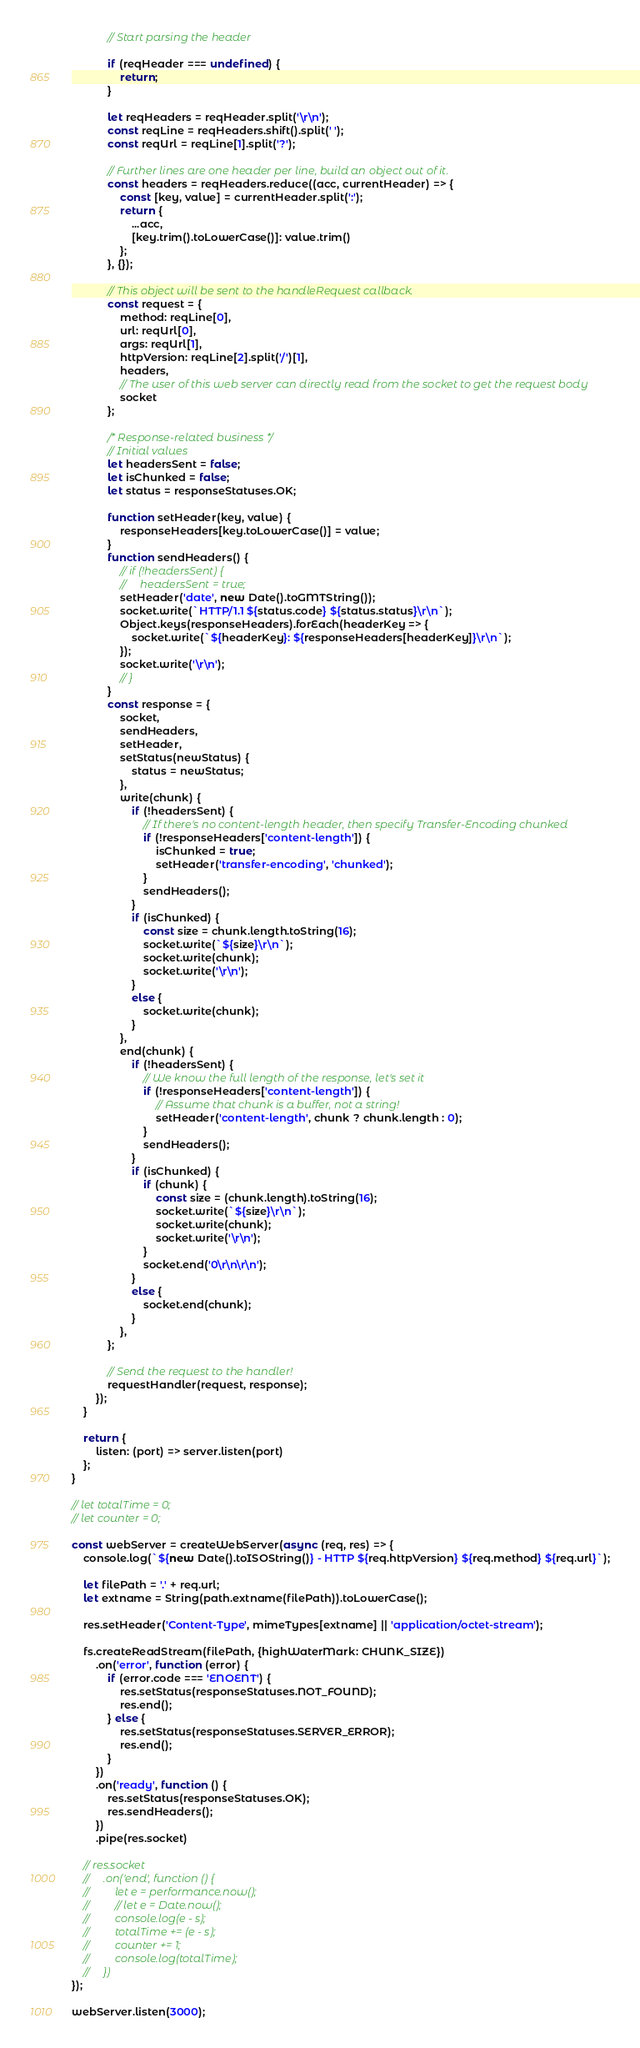Convert code to text. <code><loc_0><loc_0><loc_500><loc_500><_JavaScript_>            // Start parsing the header

            if (reqHeader === undefined) {
                return;
            }

            let reqHeaders = reqHeader.split('\r\n');
            const reqLine = reqHeaders.shift().split(' ');
            const reqUrl = reqLine[1].split('?');

            // Further lines are one header per line, build an object out of it.
            const headers = reqHeaders.reduce((acc, currentHeader) => {
                const [key, value] = currentHeader.split(':');
                return {
                    ...acc,
                    [key.trim().toLowerCase()]: value.trim()
                };
            }, {});

            // This object will be sent to the handleRequest callback.
            const request = {
                method: reqLine[0],
                url: reqUrl[0],
                args: reqUrl[1],
                httpVersion: reqLine[2].split('/')[1],
                headers,
                // The user of this web server can directly read from the socket to get the request body
                socket
            };

            /* Response-related business */
            // Initial values
            let headersSent = false;
            let isChunked = false;
            let status = responseStatuses.OK;

            function setHeader(key, value) {
                responseHeaders[key.toLowerCase()] = value;
            }
            function sendHeaders() {
                // if (!headersSent) {
                //     headersSent = true;
                setHeader('date', new Date().toGMTString());
                socket.write(`HTTP/1.1 ${status.code} ${status.status}\r\n`);
                Object.keys(responseHeaders).forEach(headerKey => {
                    socket.write(`${headerKey}: ${responseHeaders[headerKey]}\r\n`);
                });
                socket.write('\r\n');
                // }
            }
            const response = {
                socket,
                sendHeaders,
                setHeader,
                setStatus(newStatus) {
                    status = newStatus;
                },
                write(chunk) {
                    if (!headersSent) {
                        // If there's no content-length header, then specify Transfer-Encoding chunked
                        if (!responseHeaders['content-length']) {
                            isChunked = true;
                            setHeader('transfer-encoding', 'chunked');
                        }
                        sendHeaders();
                    }
                    if (isChunked) {
                        const size = chunk.length.toString(16);
                        socket.write(`${size}\r\n`);
                        socket.write(chunk);
                        socket.write('\r\n');
                    }
                    else {
                        socket.write(chunk);
                    }
                },
                end(chunk) {
                    if (!headersSent) {
                        // We know the full length of the response, let's set it
                        if (!responseHeaders['content-length']) {
                            // Assume that chunk is a buffer, not a string!
                            setHeader('content-length', chunk ? chunk.length : 0);
                        }
                        sendHeaders();
                    }
                    if (isChunked) {
                        if (chunk) {
                            const size = (chunk.length).toString(16);
                            socket.write(`${size}\r\n`);
                            socket.write(chunk);
                            socket.write('\r\n');
                        }
                        socket.end('0\r\n\r\n');
                    }
                    else {
                        socket.end(chunk);
                    }
                },
            };

            // Send the request to the handler!
            requestHandler(request, response);
        });
    }

    return {
        listen: (port) => server.listen(port)
    };
}

// let totalTime = 0;
// let counter = 0;

const webServer = createWebServer(async (req, res) => {
    console.log(`${new Date().toISOString()} - HTTP ${req.httpVersion} ${req.method} ${req.url}`);

    let filePath = '.' + req.url;
    let extname = String(path.extname(filePath)).toLowerCase();

    res.setHeader('Content-Type', mimeTypes[extname] || 'application/octet-stream');

    fs.createReadStream(filePath, {highWaterMark: CHUNK_SIZE})
        .on('error', function (error) {
            if (error.code === 'ENOENT') {
                res.setStatus(responseStatuses.NOT_FOUND);
                res.end();
            } else {
                res.setStatus(responseStatuses.SERVER_ERROR);
                res.end();
            }
        })
        .on('ready', function () {
            res.setStatus(responseStatuses.OK);
            res.sendHeaders();
        })
        .pipe(res.socket)

    // res.socket
    //     .on('end', function () {
    //         let e = performance.now();
    //         // let e = Date.now();
    //         console.log(e - s);
    //         totalTime += (e - s);
    //         counter += 1;
    //         console.log(totalTime);
    //     })
});

webServer.listen(3000);
</code> 